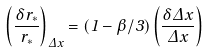Convert formula to latex. <formula><loc_0><loc_0><loc_500><loc_500>\left ( \frac { \delta r _ { * } } { r _ { * } } \right ) _ { \Delta x } = ( 1 - \beta / 3 ) \left ( \frac { \delta \Delta x } { \Delta x } \right )</formula> 